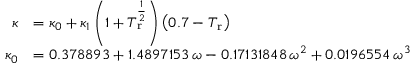Convert formula to latex. <formula><loc_0><loc_0><loc_500><loc_500>{ \begin{array} { r l } { \kappa } & { = \kappa _ { 0 } + \kappa _ { 1 } \left ( 1 + T _ { r } ^ { \frac { 1 } { 2 } } \right ) \left ( 0 . 7 - T _ { r } \right ) } \\ { \kappa _ { 0 } } & { = 0 . 3 7 8 8 9 3 + 1 . 4 8 9 7 1 5 3 \, \omega - 0 . 1 7 1 3 1 8 4 8 \, \omega ^ { 2 } + 0 . 0 1 9 6 5 5 4 \, \omega ^ { 3 } } \end{array} }</formula> 